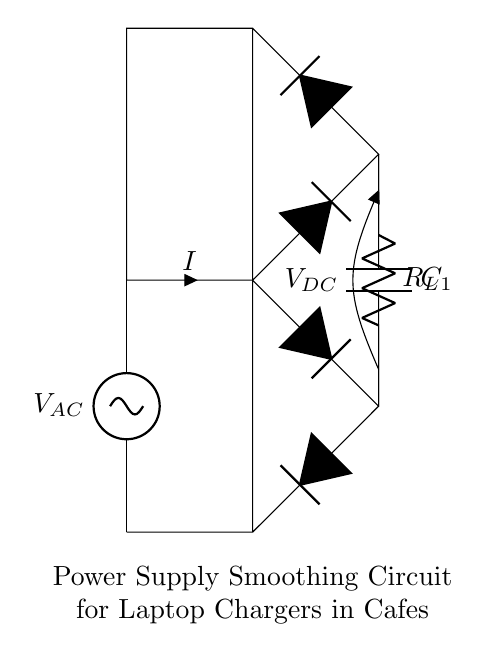what type of components are in the circuit? The components in the circuit are an AC source, diodes, a capacitor, and a resistor. The AC source provides input voltage, the diodes form a bridge rectifier, the capacitor smooths the output, and the resistor serves as a load.
Answer: AC source, diodes, capacitor, resistor what is the role of the smoothing capacitor? The role of the smoothing capacitor is to reduce voltage ripple in the output by storing and releasing electrical energy. It smooths the pulsating DC voltage from the rectifier to provide a more stable DC output.
Answer: Reduce voltage ripple how does the capacitor affect the output voltage? The capacitor increases the stability of the output voltage by storing charge during the peaks of the rectified AC and releasing it during the troughs, thereby minimizing fluctuations in the voltage.
Answer: Increases stability what is the function of the load resistor? The function of the load resistor is to provide a path for the current to flow and represents the actual load that the circuit is supplying power to. It converts electrical energy into heat or other forms of energy according to its resistance value.
Answer: Provide a load path what is the current direction in this circuit? In this circuit, the current flows from the AC source through the diodes (in a directional manner), into the capacitor and resistor, resulting in a loop that returns to the source. The diodes ensure that current only flows in one direction to charge the capacitor.
Answer: From AC source through diodes what is the voltage across the smoothing capacitor? The voltage across the smoothing capacitor closely follows the peak voltage of the rectified AC input minus the voltage drops across the diodes in the bridge rectifier, typically resulting in a higher DC voltage.
Answer: Peak voltage minus diode drops 